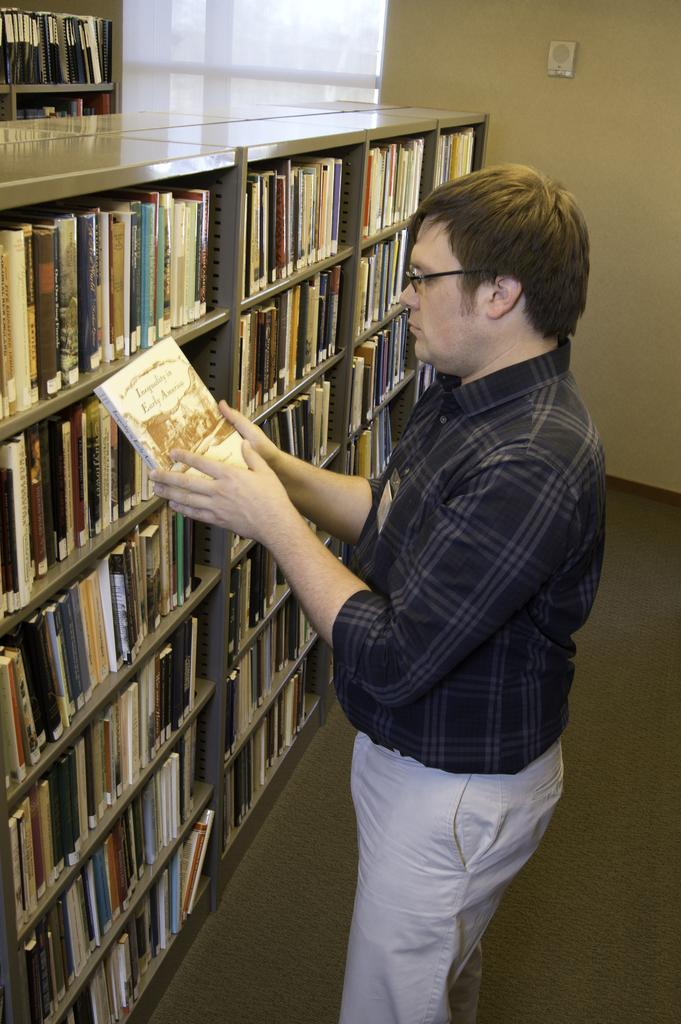Who is present in the image? There is a person in the image. What is the person wearing? The person is wearing a black shirt. What is the person doing in the image? The person is standing. What is the person holding in his hand? The person is holding a book in his hand. What can be seen behind the person? There are bookshelves in front of the person. What direction is the person facing in the image? The provided facts do not mention the direction the person is facing, so it cannot be determined from the image. What type of spark can be seen coming from the book in the person's hand? There is no spark present in the image; the person is simply holding a book. 